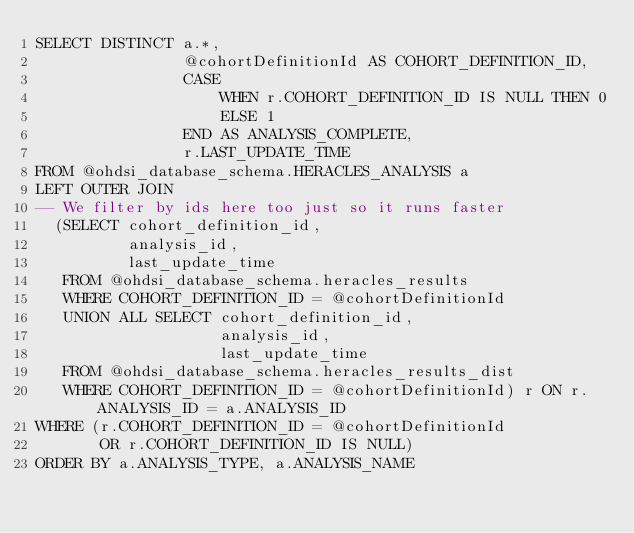<code> <loc_0><loc_0><loc_500><loc_500><_SQL_>SELECT DISTINCT a.*,
                @cohortDefinitionId AS COHORT_DEFINITION_ID,
                CASE
                    WHEN r.COHORT_DEFINITION_ID IS NULL THEN 0
                    ELSE 1
                END AS ANALYSIS_COMPLETE,
                r.LAST_UPDATE_TIME
FROM @ohdsi_database_schema.HERACLES_ANALYSIS a
LEFT OUTER JOIN 
-- We filter by ids here too just so it runs faster
  (SELECT cohort_definition_id,
          analysis_id,
          last_update_time
   FROM @ohdsi_database_schema.heracles_results
   WHERE COHORT_DEFINITION_ID = @cohortDefinitionId
   UNION ALL SELECT cohort_definition_id,
                    analysis_id,
                    last_update_time
   FROM @ohdsi_database_schema.heracles_results_dist
   WHERE COHORT_DEFINITION_ID = @cohortDefinitionId) r ON r.ANALYSIS_ID = a.ANALYSIS_ID
WHERE (r.COHORT_DEFINITION_ID = @cohortDefinitionId
       OR r.COHORT_DEFINITION_ID IS NULL)
ORDER BY a.ANALYSIS_TYPE, a.ANALYSIS_NAME</code> 